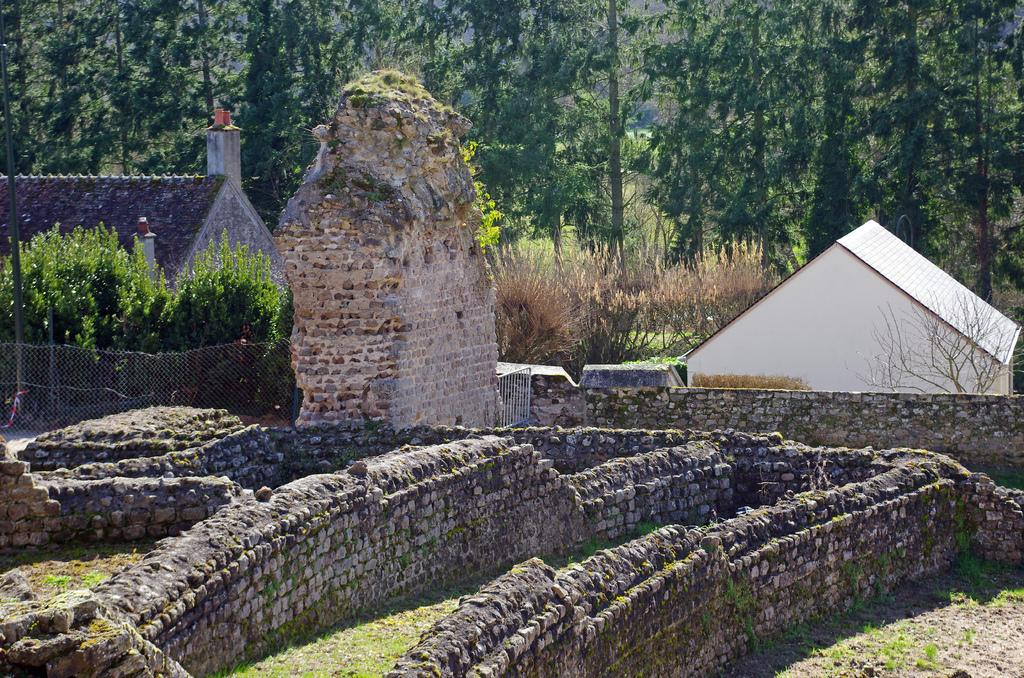What type of structure can be seen in the image? There is a wall in the image. What type of buildings are present in the image? There are houses in the image. What type of vegetation is visible in the image? Grass is visible in the image. What type of barrier is present in the image? There is a fence in the image. What type of natural elements can be seen in the image? Trees are visible in the image. What type of salt is sprinkled on the trees in the image? There is no salt present in the image; it features a wall, houses, grass, a fence, and trees. What type of joke is being told by the wall in the image? There is no joke being told in the image; it is a still image of a wall, houses, grass, a fence, and trees. 